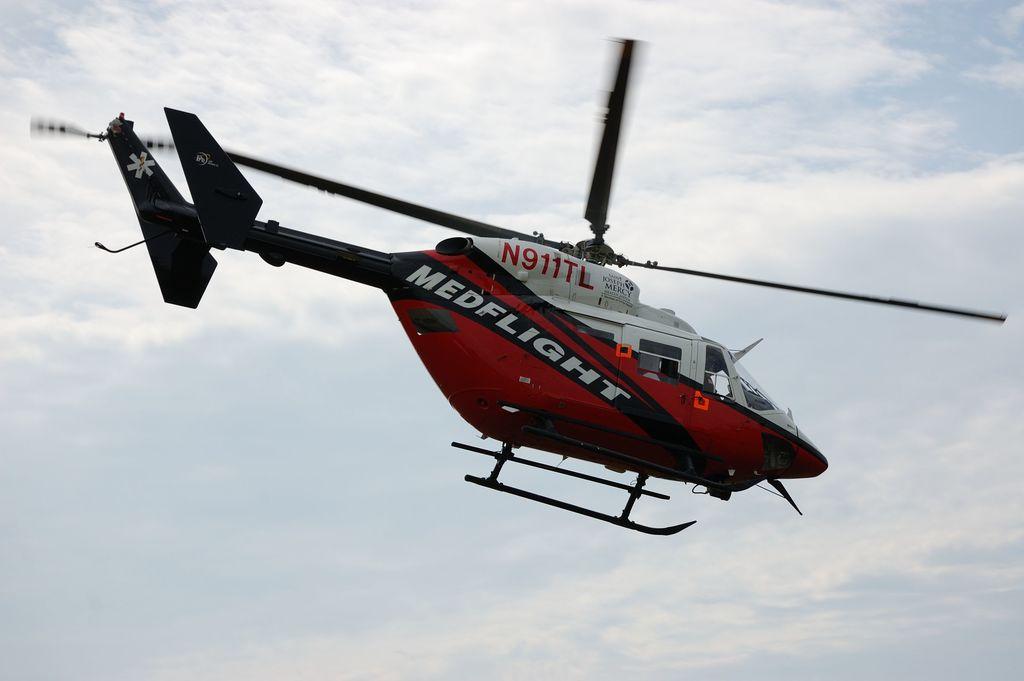What is the type of helicopter?
Keep it short and to the point. Medflight. 